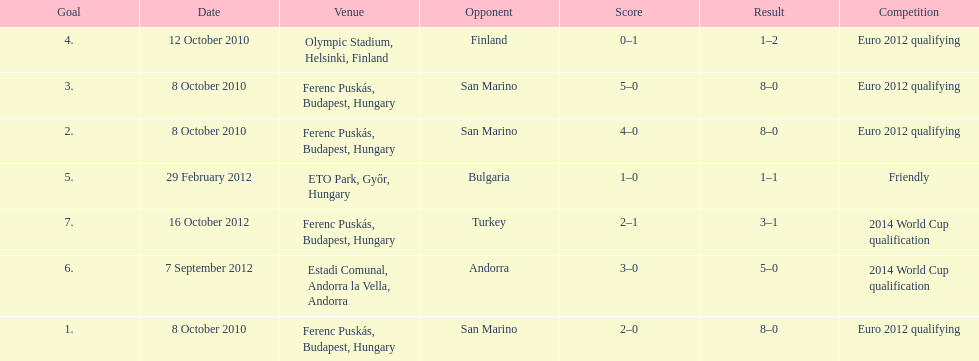When did ádám szalai make his first international goal? 8 October 2010. 